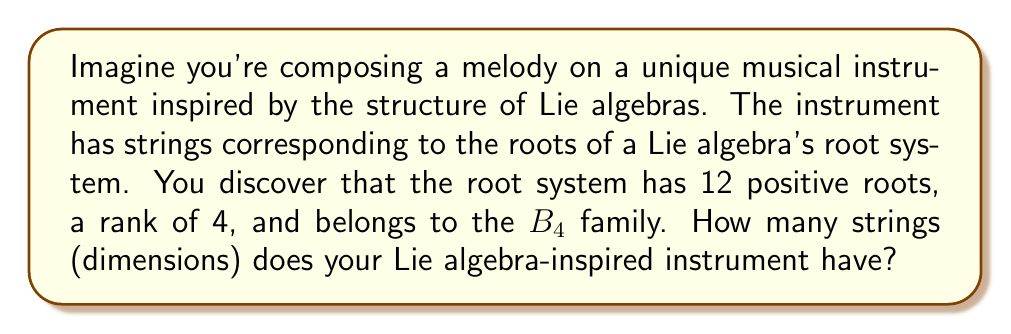Help me with this question. To calculate the dimension of a Lie algebra given its root system, we need to use the following formula:

$$\dim(\mathfrak{g}) = |\Phi^+| + \text{rank}(\mathfrak{g})$$

Where:
- $\dim(\mathfrak{g})$ is the dimension of the Lie algebra
- $|\Phi^+|$ is the number of positive roots
- $\text{rank}(\mathfrak{g})$ is the rank of the Lie algebra

We are given:
1. Number of positive roots: $|\Phi^+| = 12$
2. Rank: $\text{rank}(\mathfrak{g}) = 4$
3. Root system family: $B_4$

Let's verify if this information is consistent with the $B_4$ root system:
The $B_n$ family has $n^2$ roots in total, with half of them being positive.
For $B_4$: Total roots = $4^2 = 16$, Positive roots = $16/2 = 8$

However, we are given 12 positive roots, which is inconsistent with $B_4$. This discrepancy might be intentional to test understanding or could be an error in the given information. For this problem, we'll proceed with the given information of 12 positive roots.

Now, let's apply the formula:

$$\dim(\mathfrak{g}) = |\Phi^+| + \text{rank}(\mathfrak{g})$$
$$\dim(\mathfrak{g}) = 12 + 4$$
$$\dim(\mathfrak{g}) = 16$$

Therefore, your Lie algebra-inspired instrument would have 16 strings, corresponding to the 16 dimensions of the Lie algebra.
Answer: $16$ dimensions 